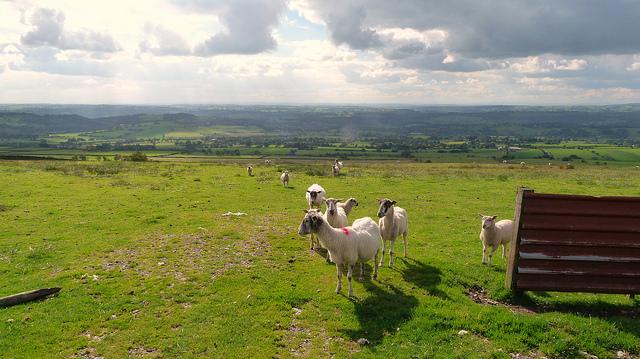What color is on the foreground animal's back?
Short answer required. Red. Is there a gate?
Concise answer only. No. Is the sun out?
Keep it brief. Yes. 